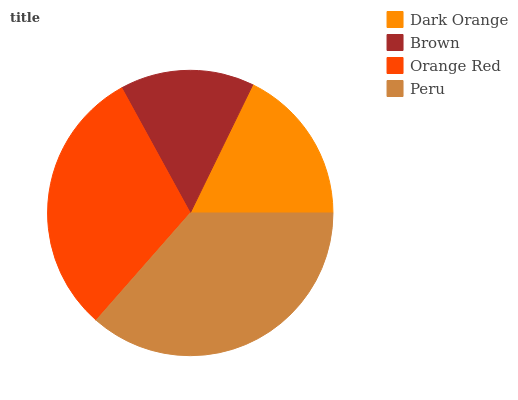Is Brown the minimum?
Answer yes or no. Yes. Is Peru the maximum?
Answer yes or no. Yes. Is Orange Red the minimum?
Answer yes or no. No. Is Orange Red the maximum?
Answer yes or no. No. Is Orange Red greater than Brown?
Answer yes or no. Yes. Is Brown less than Orange Red?
Answer yes or no. Yes. Is Brown greater than Orange Red?
Answer yes or no. No. Is Orange Red less than Brown?
Answer yes or no. No. Is Orange Red the high median?
Answer yes or no. Yes. Is Dark Orange the low median?
Answer yes or no. Yes. Is Dark Orange the high median?
Answer yes or no. No. Is Brown the low median?
Answer yes or no. No. 